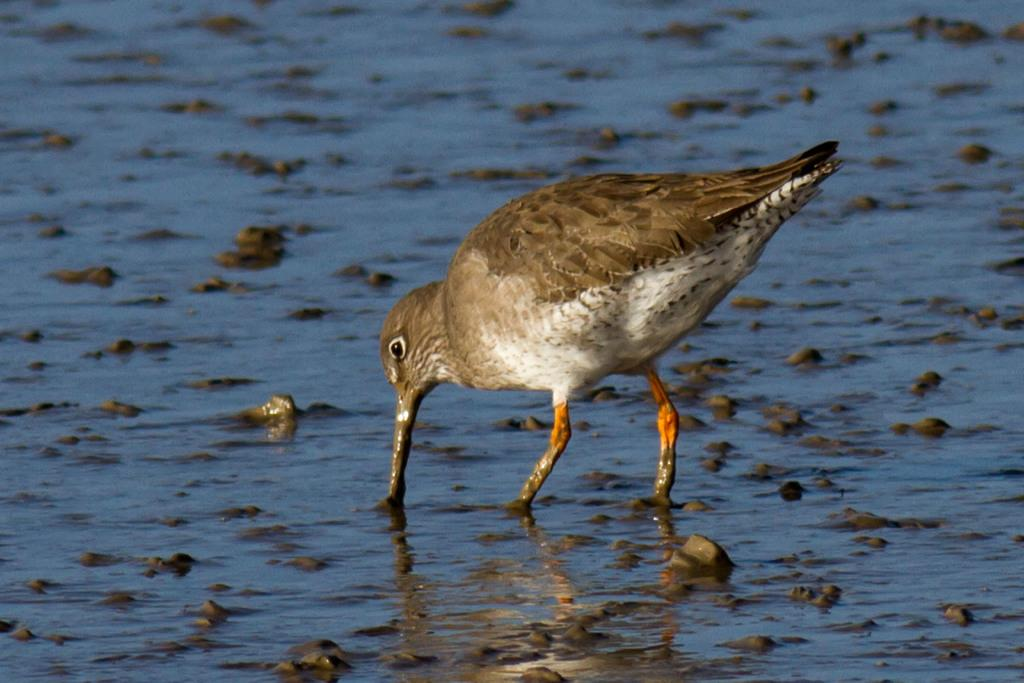What is the main subject in the center of the image? There is a bird in the center of the image. Where is the bird located? The bird is in the water. What can be seen at the bottom of the image? There is a sea at the bottom of the image. What is present within the sea? There are stones in the sea. What type of straw is being used by the bird in the image? There is no straw present in the image; the bird is in the water. 